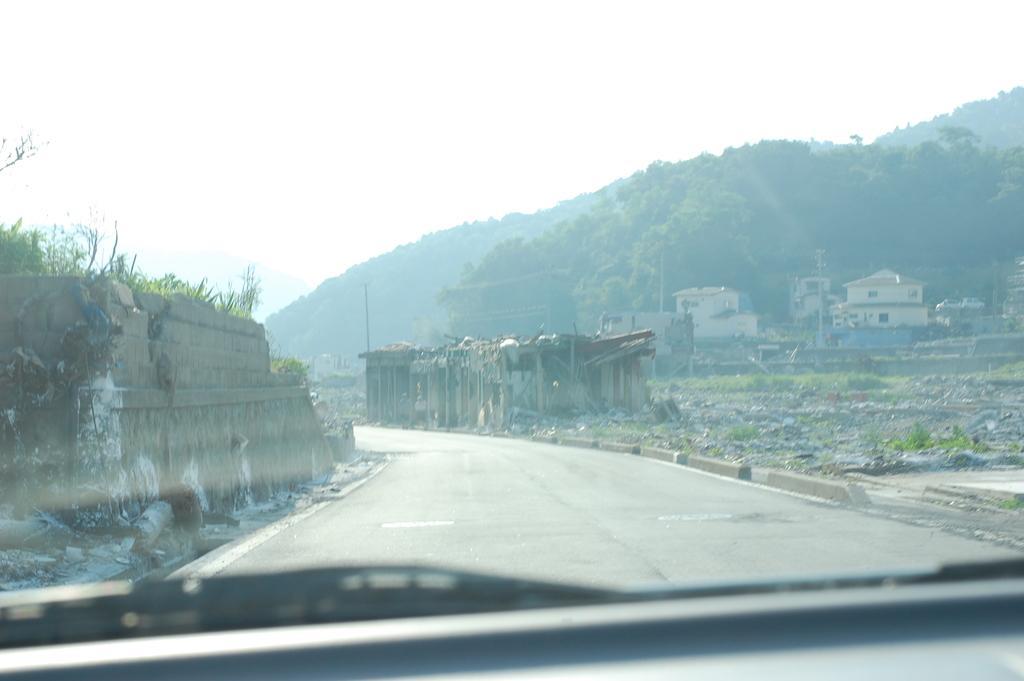In one or two sentences, can you explain what this image depicts? In this picture there is a car at the bottom side of the image, there are houses, trees, and broken walls in the center of the image. 